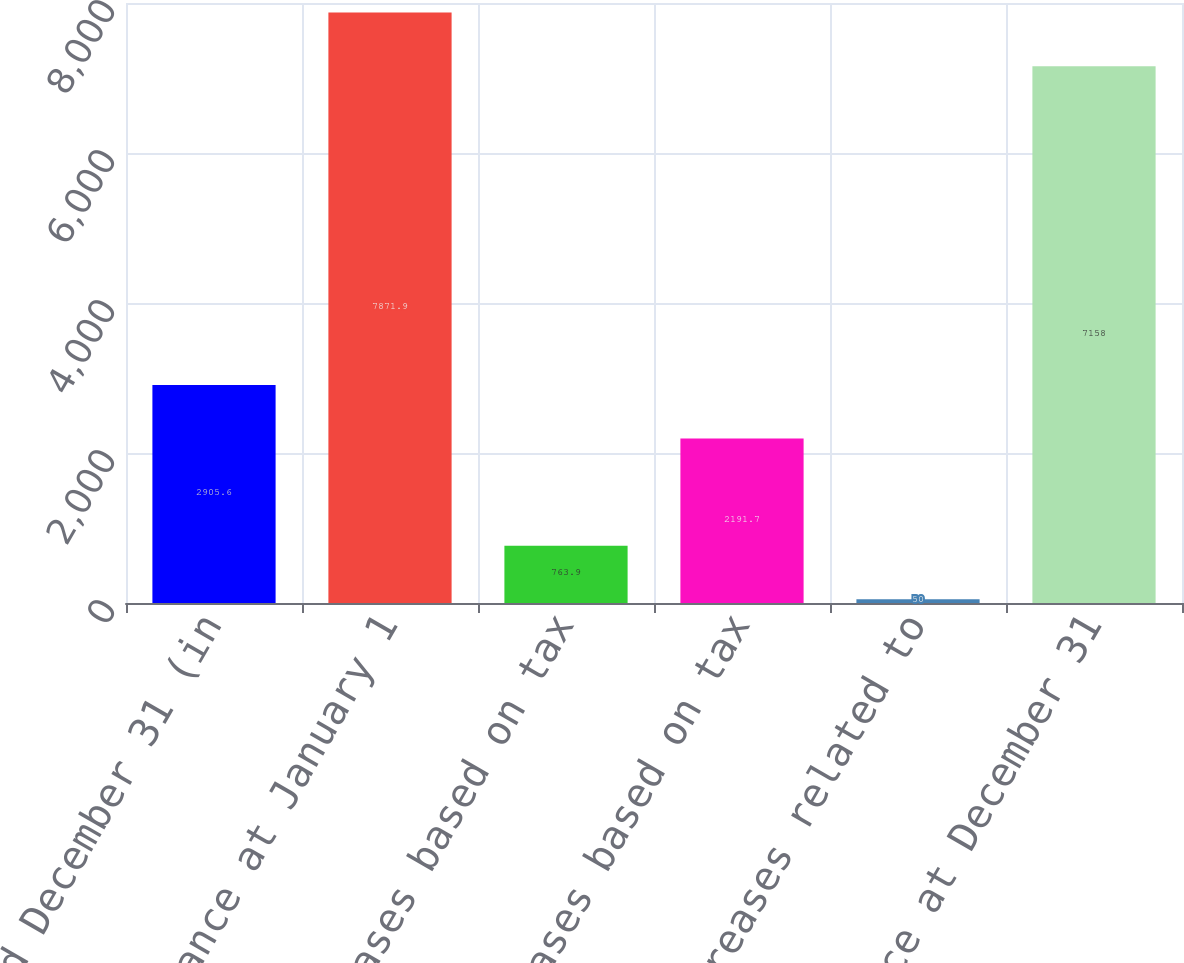Convert chart. <chart><loc_0><loc_0><loc_500><loc_500><bar_chart><fcel>Year ended December 31 (in<fcel>Balance at January 1<fcel>Increases based on tax<fcel>Decreases based on tax<fcel>Decreases related to<fcel>Balance at December 31<nl><fcel>2905.6<fcel>7871.9<fcel>763.9<fcel>2191.7<fcel>50<fcel>7158<nl></chart> 